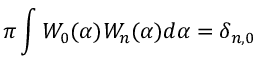<formula> <loc_0><loc_0><loc_500><loc_500>\pi \int W _ { 0 } ( \alpha ) W _ { n } ( \alpha ) d \alpha = \delta _ { n , 0 }</formula> 